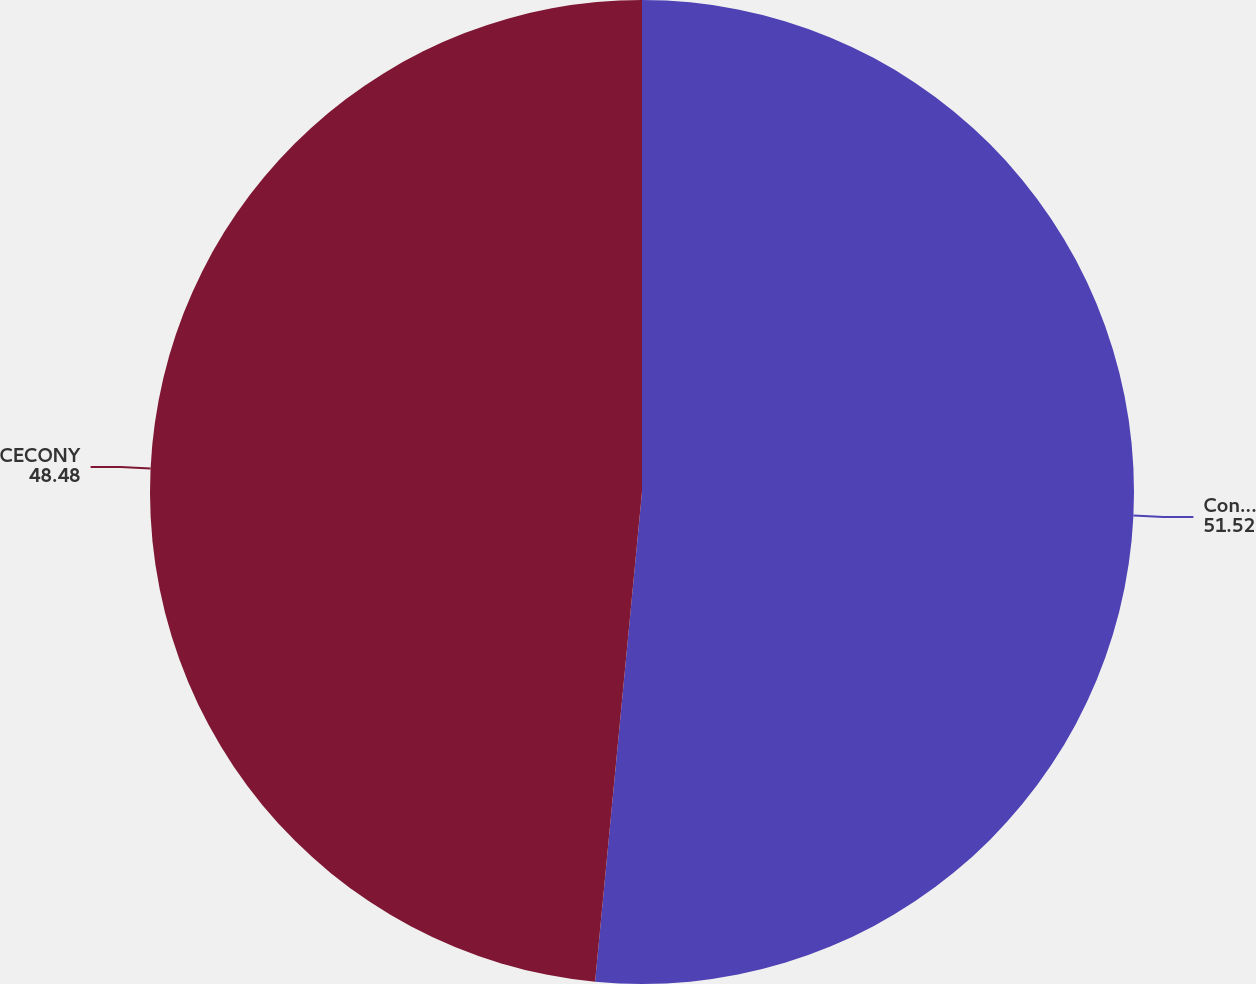Convert chart to OTSL. <chart><loc_0><loc_0><loc_500><loc_500><pie_chart><fcel>Con Edison<fcel>CECONY<nl><fcel>51.52%<fcel>48.48%<nl></chart> 